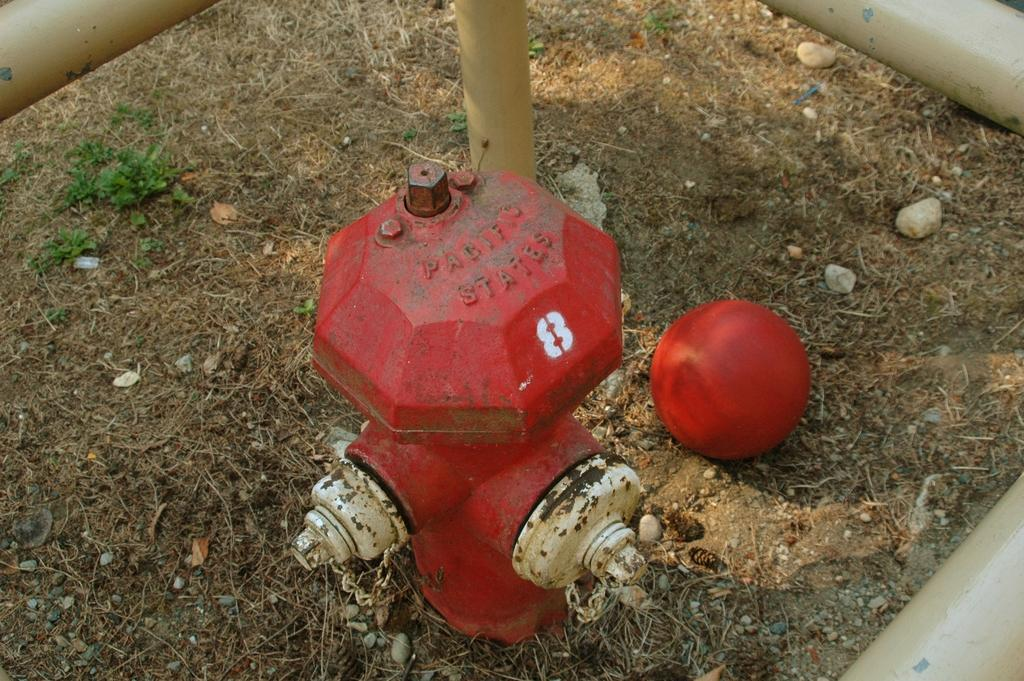What object is on the ground in the image? There is a hydrant on the ground in the image. What other object can be seen in the image? There is a ball in the image. What type of objects are the rods in the image? The rods in the image are not described in detail, so we cannot determine their type. What type of advice can be seen in the image? There is no advice present in the image; it features a hydrant, a ball, and rods. How many cherries are visible in the image? There are no cherries present in the image. 